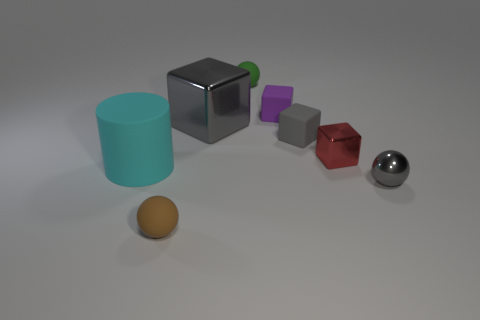Subtract all brown balls. Subtract all red cubes. How many balls are left? 2 Add 1 big yellow rubber cubes. How many objects exist? 9 Subtract all spheres. How many objects are left? 5 Add 5 brown rubber balls. How many brown rubber balls exist? 6 Subtract 0 gray cylinders. How many objects are left? 8 Subtract all large cyan matte cubes. Subtract all tiny red metal objects. How many objects are left? 7 Add 8 green balls. How many green balls are left? 9 